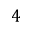Convert formula to latex. <formula><loc_0><loc_0><loc_500><loc_500>4</formula> 